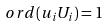Convert formula to latex. <formula><loc_0><loc_0><loc_500><loc_500>o r d ( u _ { i } U _ { i } ) = 1</formula> 